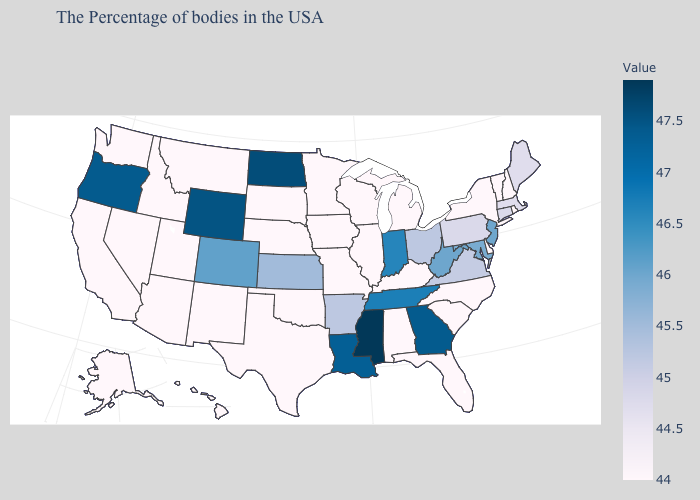Does Mississippi have the highest value in the USA?
Keep it brief. Yes. Which states have the lowest value in the USA?
Give a very brief answer. Rhode Island, New Hampshire, Vermont, New York, Delaware, North Carolina, South Carolina, Florida, Michigan, Kentucky, Alabama, Wisconsin, Illinois, Missouri, Minnesota, Iowa, Nebraska, Oklahoma, Texas, South Dakota, New Mexico, Utah, Montana, Arizona, Idaho, Nevada, California, Washington, Alaska, Hawaii. 